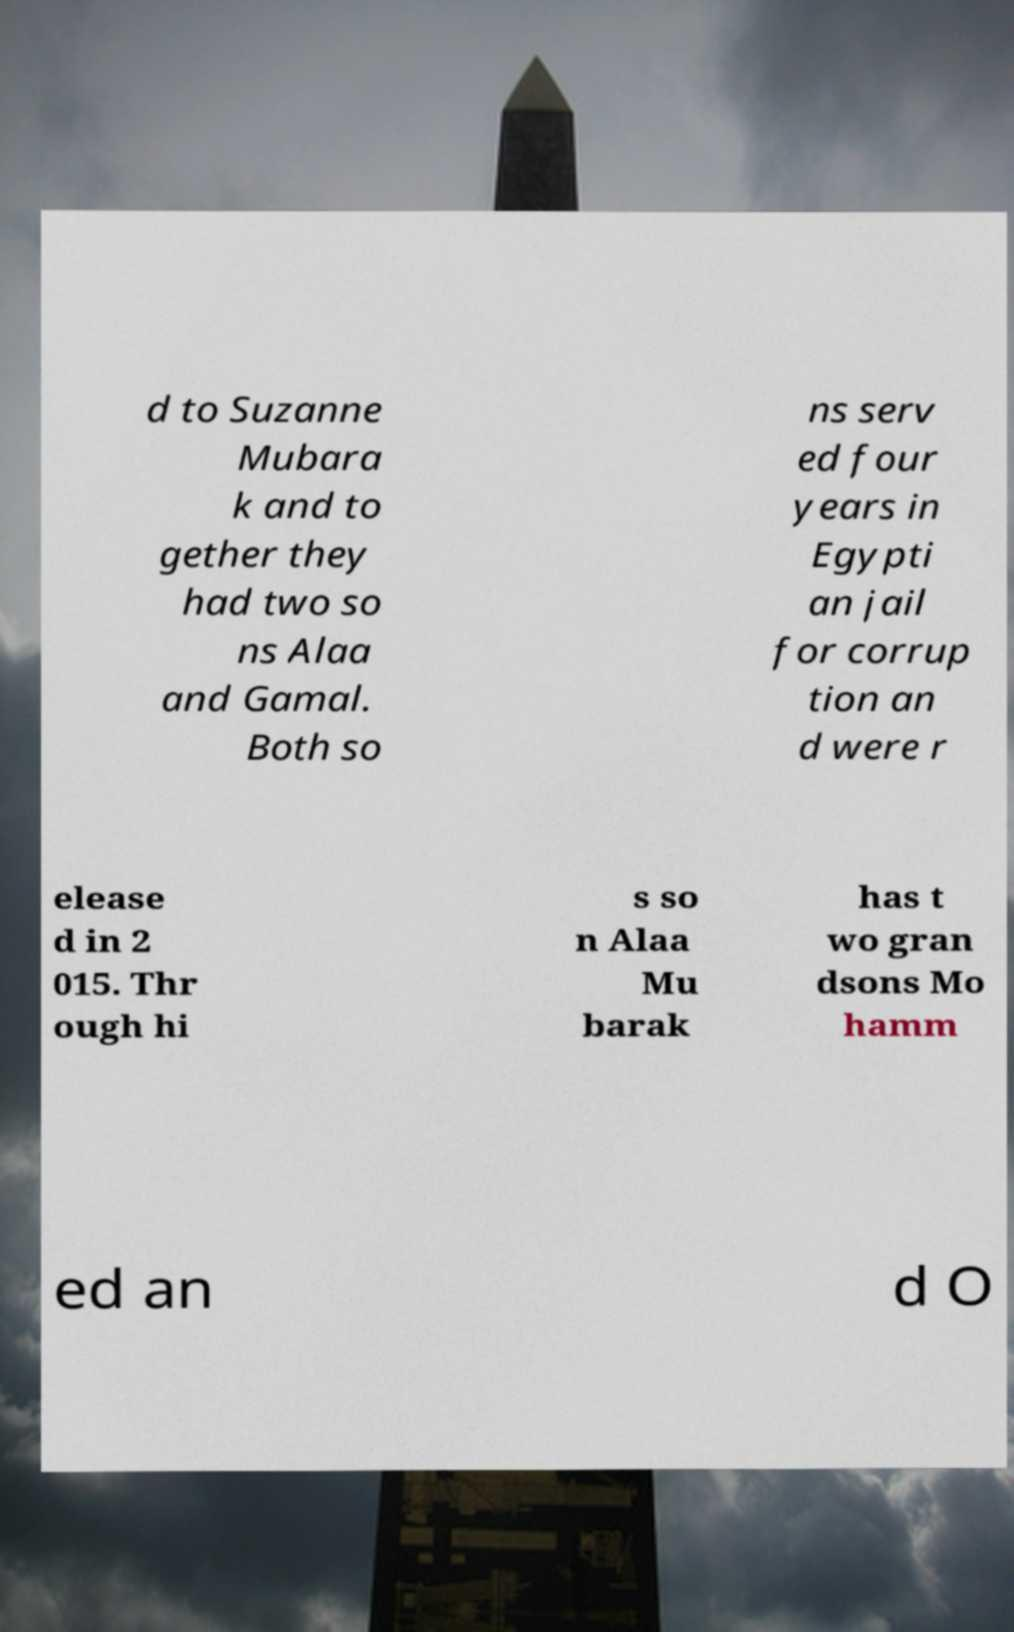Can you accurately transcribe the text from the provided image for me? d to Suzanne Mubara k and to gether they had two so ns Alaa and Gamal. Both so ns serv ed four years in Egypti an jail for corrup tion an d were r elease d in 2 015. Thr ough hi s so n Alaa Mu barak has t wo gran dsons Mo hamm ed an d O 